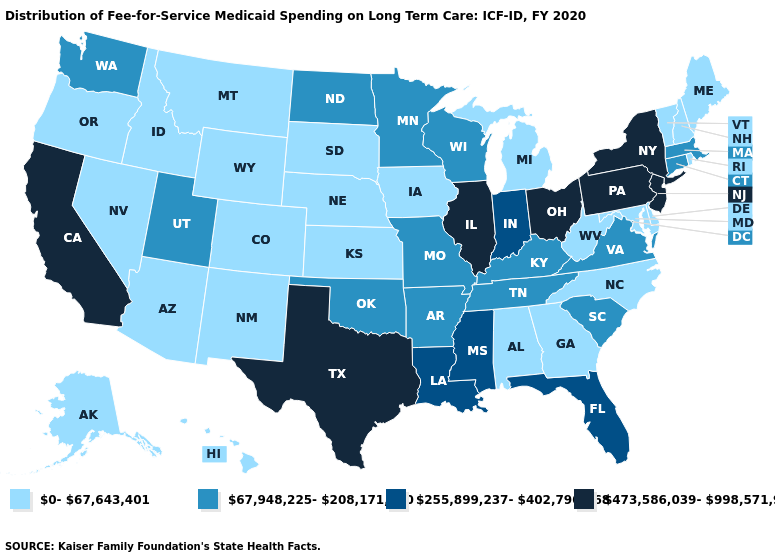Does California have the highest value in the West?
Quick response, please. Yes. Is the legend a continuous bar?
Short answer required. No. What is the value of Indiana?
Give a very brief answer. 255,899,237-402,790,168. What is the lowest value in the USA?
Give a very brief answer. 0-67,643,401. Does the map have missing data?
Concise answer only. No. What is the value of Vermont?
Give a very brief answer. 0-67,643,401. Name the states that have a value in the range 0-67,643,401?
Answer briefly. Alabama, Alaska, Arizona, Colorado, Delaware, Georgia, Hawaii, Idaho, Iowa, Kansas, Maine, Maryland, Michigan, Montana, Nebraska, Nevada, New Hampshire, New Mexico, North Carolina, Oregon, Rhode Island, South Dakota, Vermont, West Virginia, Wyoming. How many symbols are there in the legend?
Quick response, please. 4. Does Alabama have the lowest value in the USA?
Short answer required. Yes. Which states have the highest value in the USA?
Keep it brief. California, Illinois, New Jersey, New York, Ohio, Pennsylvania, Texas. Which states hav the highest value in the South?
Short answer required. Texas. Which states have the lowest value in the Northeast?
Be succinct. Maine, New Hampshire, Rhode Island, Vermont. Name the states that have a value in the range 67,948,225-208,171,790?
Short answer required. Arkansas, Connecticut, Kentucky, Massachusetts, Minnesota, Missouri, North Dakota, Oklahoma, South Carolina, Tennessee, Utah, Virginia, Washington, Wisconsin. Does Kansas have the same value as Utah?
Write a very short answer. No. 